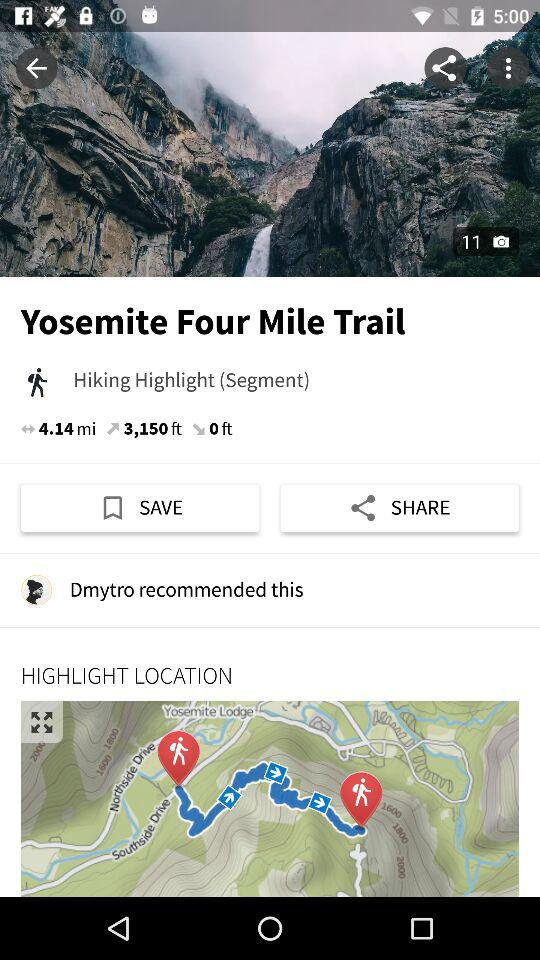What is the elevation? The elevation is 3,150 ft. 